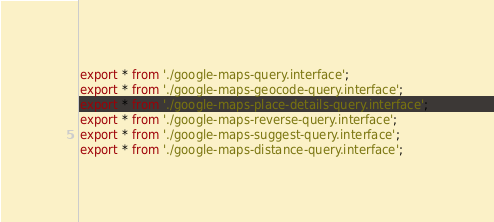Convert code to text. <code><loc_0><loc_0><loc_500><loc_500><_TypeScript_>export * from './google-maps-query.interface';
export * from './google-maps-geocode-query.interface';
export * from './google-maps-place-details-query.interface';
export * from './google-maps-reverse-query.interface';
export * from './google-maps-suggest-query.interface';
export * from './google-maps-distance-query.interface';
</code> 